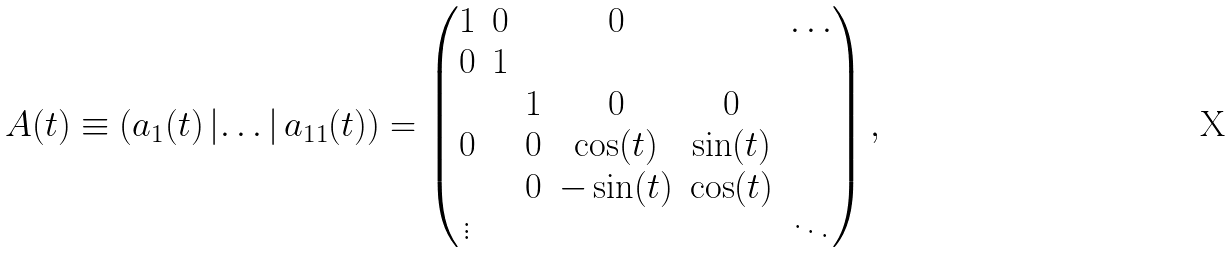Convert formula to latex. <formula><loc_0><loc_0><loc_500><loc_500>\ A ( t ) \equiv \left ( a _ { 1 } ( t ) \left | \dots \right | a _ { 1 1 } ( t ) \right ) = \begin{pmatrix} 1 & 0 & & 0 & & \dots \\ 0 & 1 \\ & & 1 & 0 & 0 \\ 0 & & 0 & \cos ( t ) & \sin ( t ) \\ & & 0 & - \sin ( t ) & \cos ( t ) \\ \vdots & & & & & \ddots \end{pmatrix} ,</formula> 